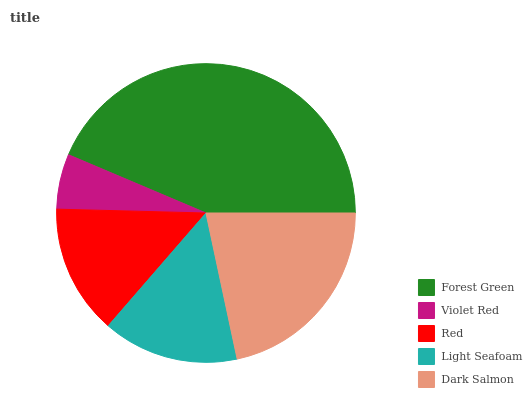Is Violet Red the minimum?
Answer yes or no. Yes. Is Forest Green the maximum?
Answer yes or no. Yes. Is Red the minimum?
Answer yes or no. No. Is Red the maximum?
Answer yes or no. No. Is Red greater than Violet Red?
Answer yes or no. Yes. Is Violet Red less than Red?
Answer yes or no. Yes. Is Violet Red greater than Red?
Answer yes or no. No. Is Red less than Violet Red?
Answer yes or no. No. Is Light Seafoam the high median?
Answer yes or no. Yes. Is Light Seafoam the low median?
Answer yes or no. Yes. Is Red the high median?
Answer yes or no. No. Is Forest Green the low median?
Answer yes or no. No. 